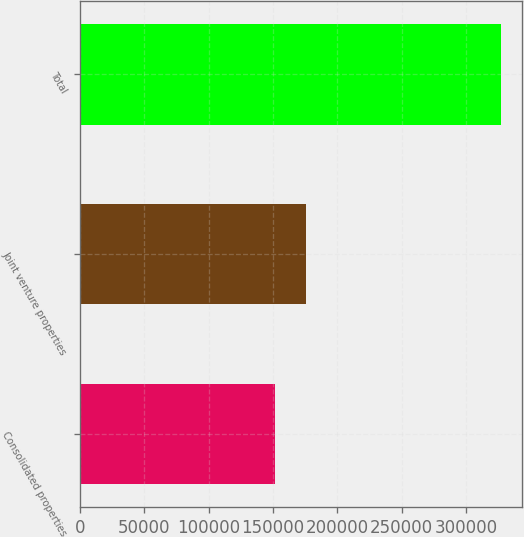<chart> <loc_0><loc_0><loc_500><loc_500><bar_chart><fcel>Consolidated properties<fcel>Joint venture properties<fcel>Total<nl><fcel>151502<fcel>175985<fcel>327487<nl></chart> 